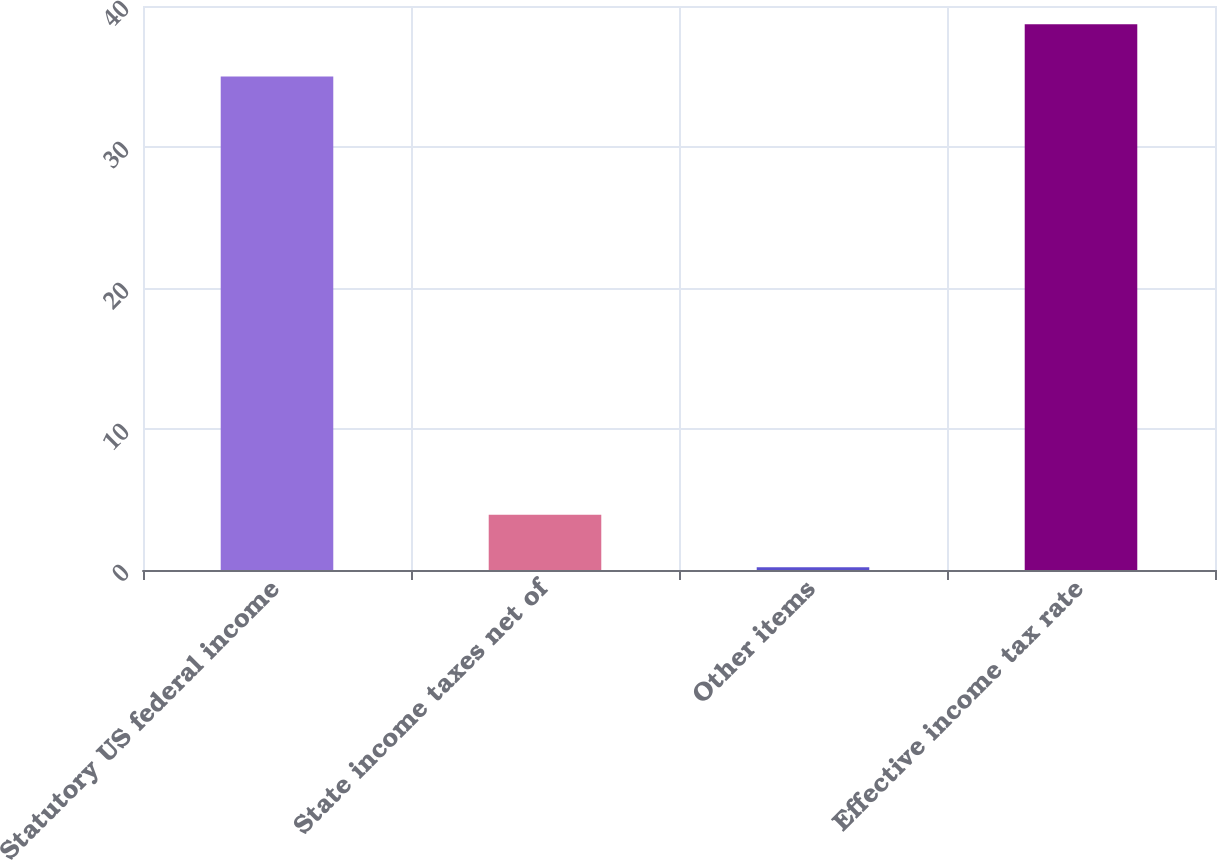Convert chart to OTSL. <chart><loc_0><loc_0><loc_500><loc_500><bar_chart><fcel>Statutory US federal income<fcel>State income taxes net of<fcel>Other items<fcel>Effective income tax rate<nl><fcel>35<fcel>3.91<fcel>0.2<fcel>38.71<nl></chart> 